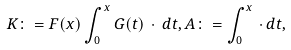Convert formula to latex. <formula><loc_0><loc_0><loc_500><loc_500>K \colon = F ( x ) \int _ { 0 } ^ { x } G ( t ) \, \cdot \, d t , A \colon = \int _ { 0 } ^ { x } \, \cdot \, d t ,</formula> 